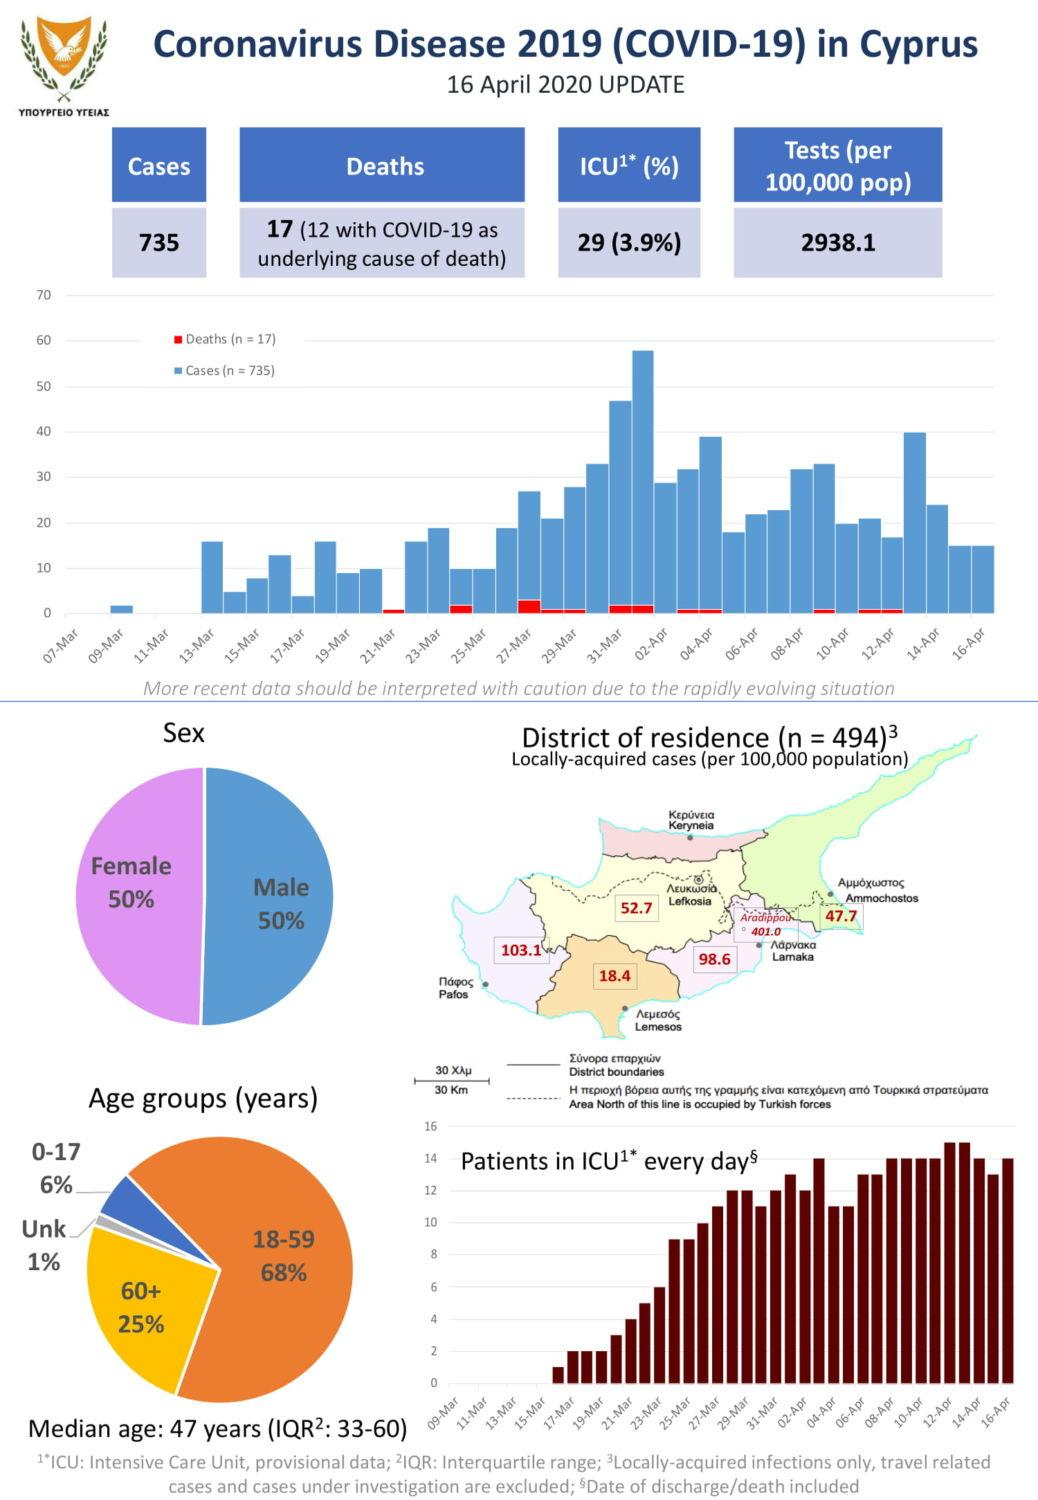Point out several critical features in this image. According to the pie chart, senior citizens make up 25% of the population. 